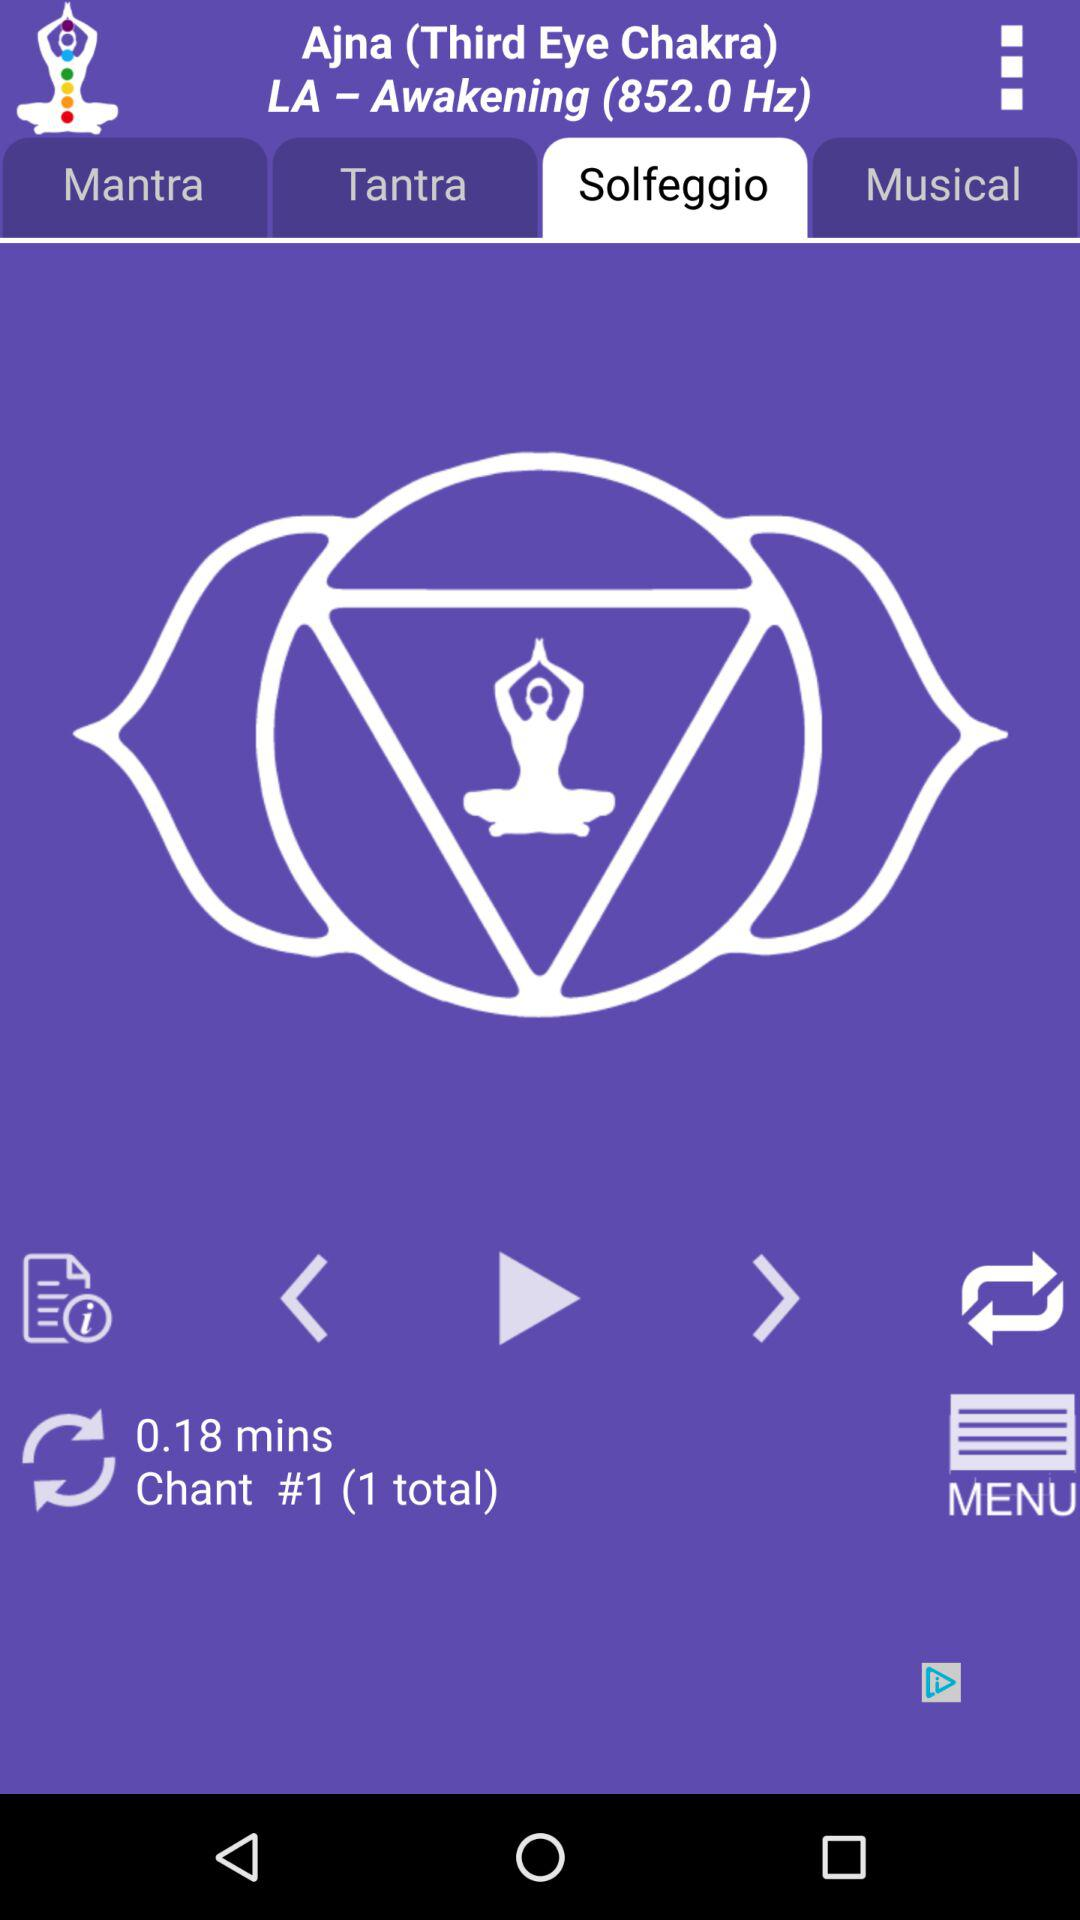What solfeggio is currently being performed? The solfeggio currently being performed is "LA - Awakening (852.0 Hz)". 